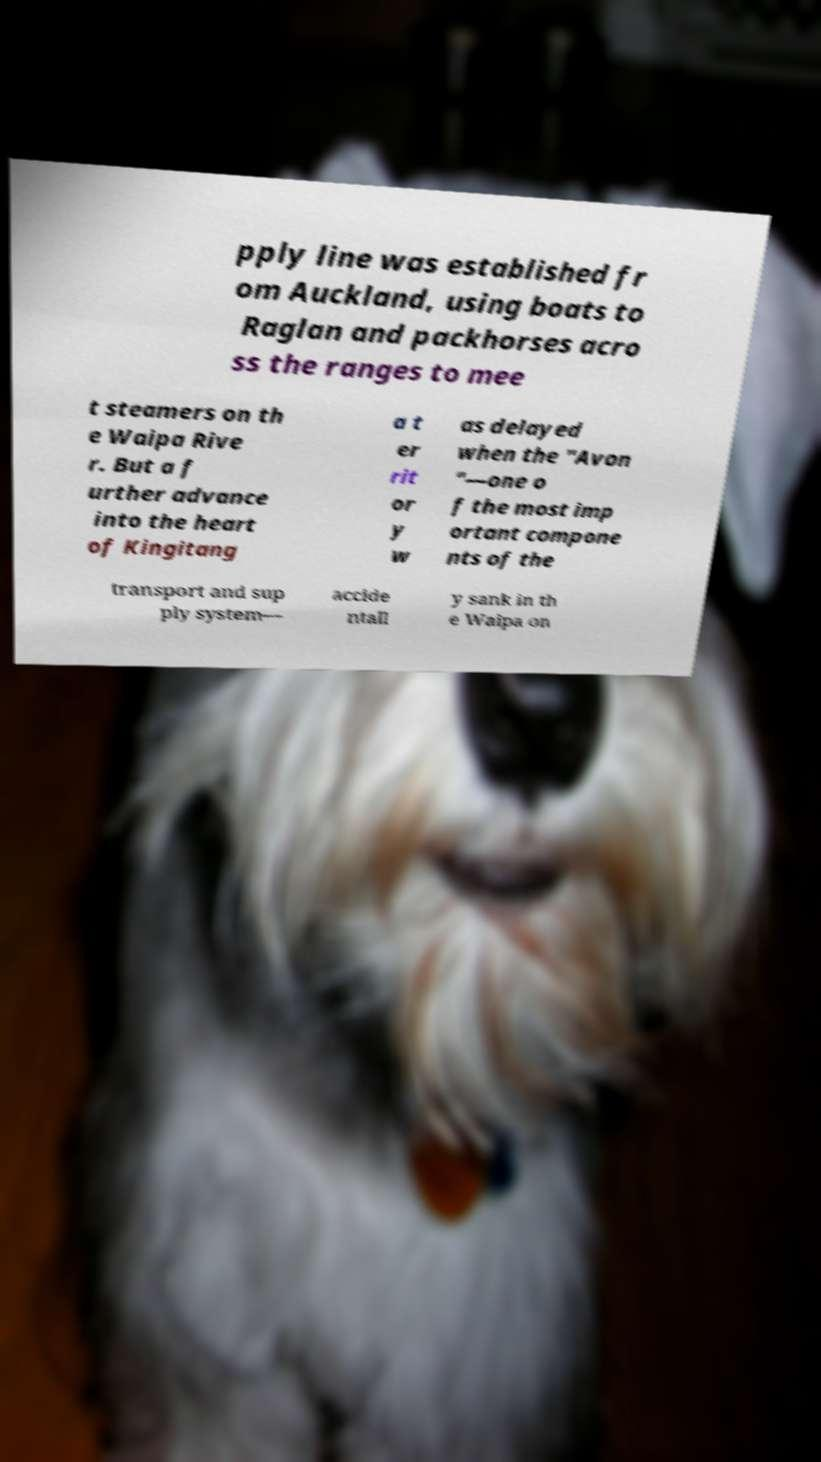What messages or text are displayed in this image? I need them in a readable, typed format. pply line was established fr om Auckland, using boats to Raglan and packhorses acro ss the ranges to mee t steamers on th e Waipa Rive r. But a f urther advance into the heart of Kingitang a t er rit or y w as delayed when the "Avon "—one o f the most imp ortant compone nts of the transport and sup ply system— accide ntall y sank in th e Waipa on 